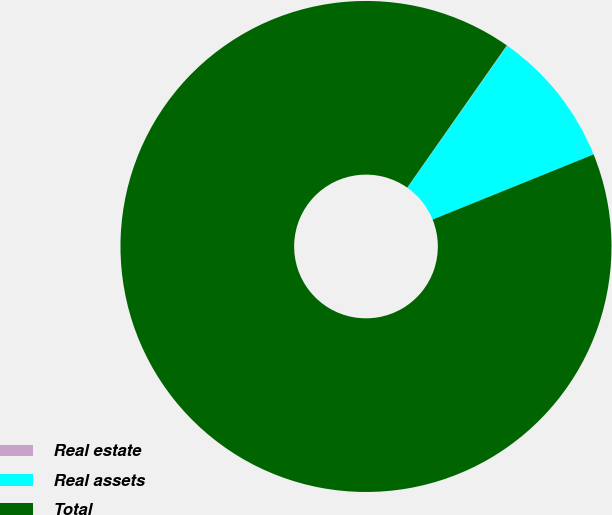Convert chart. <chart><loc_0><loc_0><loc_500><loc_500><pie_chart><fcel>Real estate<fcel>Real assets<fcel>Total<nl><fcel>0.04%<fcel>9.12%<fcel>90.83%<nl></chart> 